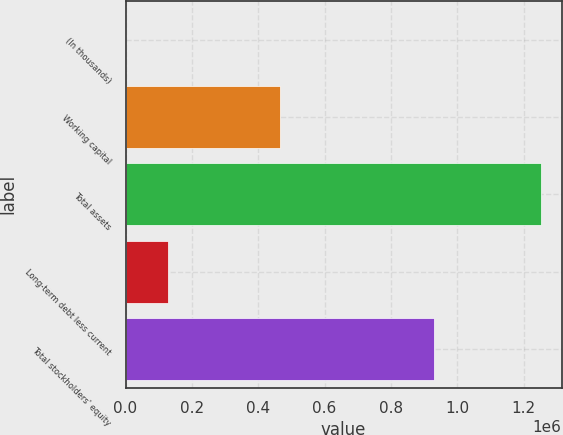Convert chart. <chart><loc_0><loc_0><loc_500><loc_500><bar_chart><fcel>(In thousands)<fcel>Working capital<fcel>Total assets<fcel>Long-term debt less current<fcel>Total stockholders' equity<nl><fcel>2007<fcel>466396<fcel>1.25204e+06<fcel>127010<fcel>931222<nl></chart> 